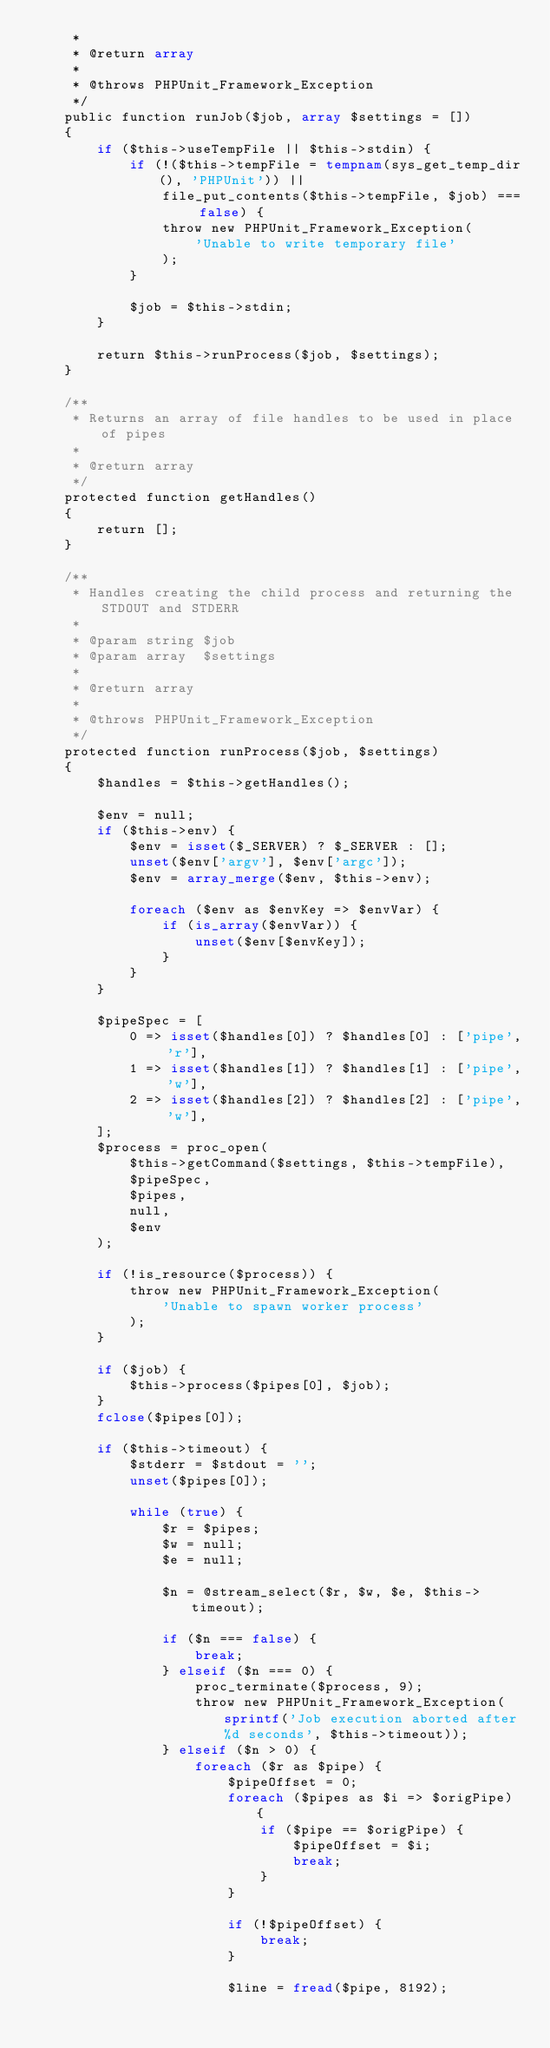Convert code to text. <code><loc_0><loc_0><loc_500><loc_500><_PHP_>     *
     * @return array
     *
     * @throws PHPUnit_Framework_Exception
     */
    public function runJob($job, array $settings = [])
    {
        if ($this->useTempFile || $this->stdin) {
            if (!($this->tempFile = tempnam(sys_get_temp_dir(), 'PHPUnit')) ||
                file_put_contents($this->tempFile, $job) === false) {
                throw new PHPUnit_Framework_Exception(
                    'Unable to write temporary file'
                );
            }

            $job = $this->stdin;
        }

        return $this->runProcess($job, $settings);
    }

    /**
     * Returns an array of file handles to be used in place of pipes
     *
     * @return array
     */
    protected function getHandles()
    {
        return [];
    }

    /**
     * Handles creating the child process and returning the STDOUT and STDERR
     *
     * @param string $job
     * @param array  $settings
     *
     * @return array
     *
     * @throws PHPUnit_Framework_Exception
     */
    protected function runProcess($job, $settings)
    {
        $handles = $this->getHandles();

        $env = null;
        if ($this->env) {
            $env = isset($_SERVER) ? $_SERVER : [];
            unset($env['argv'], $env['argc']);
            $env = array_merge($env, $this->env);

            foreach ($env as $envKey => $envVar) {
                if (is_array($envVar)) {
                    unset($env[$envKey]);
                }
            }
        }

        $pipeSpec = [
            0 => isset($handles[0]) ? $handles[0] : ['pipe', 'r'],
            1 => isset($handles[1]) ? $handles[1] : ['pipe', 'w'],
            2 => isset($handles[2]) ? $handles[2] : ['pipe', 'w'],
        ];
        $process = proc_open(
            $this->getCommand($settings, $this->tempFile),
            $pipeSpec,
            $pipes,
            null,
            $env
        );

        if (!is_resource($process)) {
            throw new PHPUnit_Framework_Exception(
                'Unable to spawn worker process'
            );
        }

        if ($job) {
            $this->process($pipes[0], $job);
        }
        fclose($pipes[0]);

        if ($this->timeout) {
            $stderr = $stdout = '';
            unset($pipes[0]);

            while (true) {
                $r = $pipes;
                $w = null;
                $e = null;

                $n = @stream_select($r, $w, $e, $this->timeout);

                if ($n === false) {
                    break;
                } elseif ($n === 0) {
                    proc_terminate($process, 9);
                    throw new PHPUnit_Framework_Exception(sprintf('Job execution aborted after %d seconds', $this->timeout));
                } elseif ($n > 0) {
                    foreach ($r as $pipe) {
                        $pipeOffset = 0;
                        foreach ($pipes as $i => $origPipe) {
                            if ($pipe == $origPipe) {
                                $pipeOffset = $i;
                                break;
                            }
                        }

                        if (!$pipeOffset) {
                            break;
                        }

                        $line = fread($pipe, 8192);</code> 